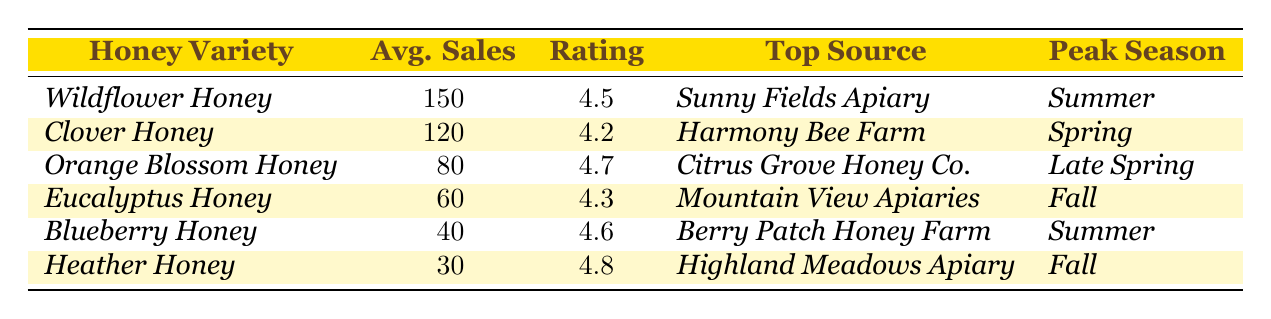What is the honey variety with the highest average sales? According to the table, *Wildflower Honey* has the highest average sales at 150.
Answer: Wildflower Honey Which honey variety has the highest customer rating? Looking at the customer ratings in the table, *Heather Honey* has the highest rating of 4.8.
Answer: Heather Honey What are the average sales of *Clover Honey*? The table indicates that the average sales for *Clover Honey* are 120.
Answer: 120 Which honey variety has its peak season in the fall? The table shows that both *Eucalyptus Honey* and *Heather Honey* have their peak season in the fall.
Answer: Eucalyptus Honey and Heather Honey What is the average sales of *Orange Blossom Honey* compared to *Blueberry Honey*? The average sales for *Orange Blossom Honey* are 80 and for *Blueberry Honey* are 40. So, 80 - 40 = 40.
Answer: 40 Is *Sunny Fields Apiary* the top source for the honey variety with the highest customer rating? *Sunny Fields Apiary* is the top source for *Wildflower Honey*, which has a customer rating of 4.5. However, *Heather Honey* has the highest rating of 4.8 and its top source is *Highland Meadows Apiary*, so the statement is false.
Answer: No What are the average sales for honey varieties that peak in summer? The honey varieties that peak in summer are *Wildflower Honey* (150) and *Blueberry Honey* (40). Adding these gives us 150 + 40 = 190.
Answer: 190 Which honey has the second highest average sales and what is its customer rating? The second highest average sales belong to *Clover Honey* at 120 with a customer rating of 4.2.
Answer: Clover Honey, 4.2 Does *Clover Honey* have a higher or lower average sales than the average of all honey varieties combined? The total average sales for all honey varieties combined are (150 + 120 + 80 + 60 + 40 + 30) = 480, divided by 6 honey varieties gives an average of 80. *Clover Honey*'s average sales of 120 is higher than this average.
Answer: Higher What is the peak season for the honey variety with the lowest average sales? The table shows that *Heather Honey* has the lowest average sales at 30 and its peak season is *Fall*.
Answer: Fall 